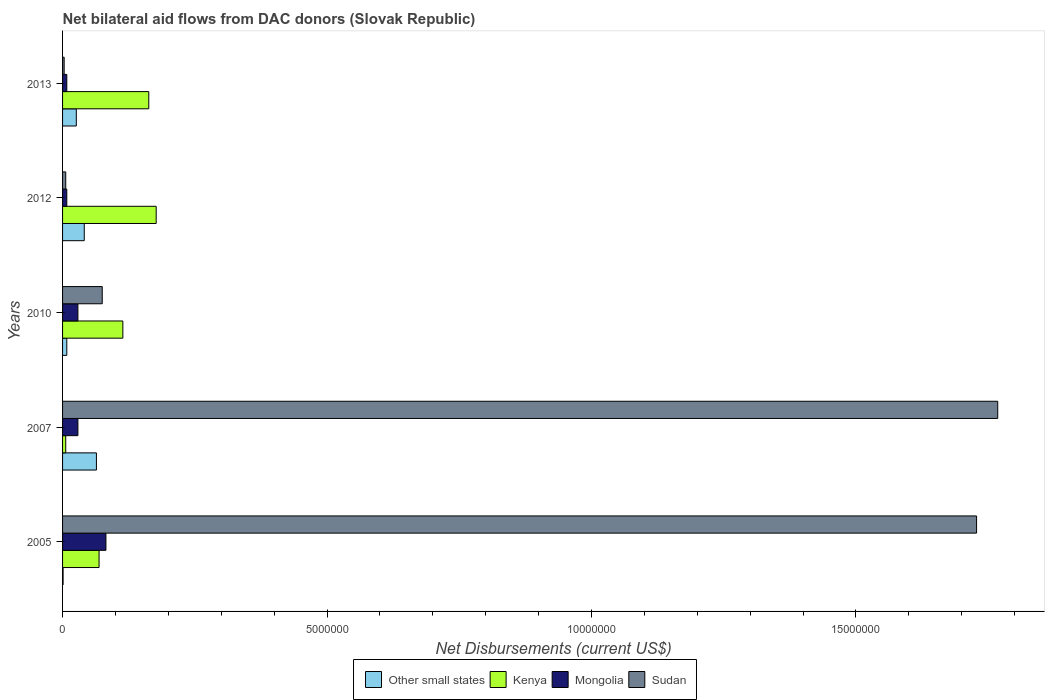How many different coloured bars are there?
Give a very brief answer. 4. How many groups of bars are there?
Ensure brevity in your answer.  5. Are the number of bars per tick equal to the number of legend labels?
Provide a short and direct response. Yes. What is the label of the 2nd group of bars from the top?
Your answer should be very brief. 2012. In how many cases, is the number of bars for a given year not equal to the number of legend labels?
Make the answer very short. 0. Across all years, what is the maximum net bilateral aid flows in Mongolia?
Your answer should be very brief. 8.20e+05. What is the total net bilateral aid flows in Kenya in the graph?
Your answer should be very brief. 5.29e+06. What is the difference between the net bilateral aid flows in Sudan in 2005 and that in 2007?
Offer a very short reply. -4.00e+05. What is the difference between the net bilateral aid flows in Other small states in 2007 and the net bilateral aid flows in Kenya in 2012?
Give a very brief answer. -1.13e+06. In the year 2013, what is the difference between the net bilateral aid flows in Kenya and net bilateral aid flows in Sudan?
Provide a short and direct response. 1.60e+06. What is the ratio of the net bilateral aid flows in Other small states in 2010 to that in 2013?
Your response must be concise. 0.31. What is the difference between the highest and the lowest net bilateral aid flows in Other small states?
Your answer should be very brief. 6.30e+05. Is the sum of the net bilateral aid flows in Other small states in 2007 and 2012 greater than the maximum net bilateral aid flows in Mongolia across all years?
Your answer should be compact. Yes. Is it the case that in every year, the sum of the net bilateral aid flows in Mongolia and net bilateral aid flows in Sudan is greater than the sum of net bilateral aid flows in Kenya and net bilateral aid flows in Other small states?
Ensure brevity in your answer.  No. What does the 2nd bar from the top in 2007 represents?
Offer a very short reply. Mongolia. What does the 3rd bar from the bottom in 2012 represents?
Ensure brevity in your answer.  Mongolia. How many bars are there?
Keep it short and to the point. 20. Are all the bars in the graph horizontal?
Your answer should be very brief. Yes. How many years are there in the graph?
Keep it short and to the point. 5. Are the values on the major ticks of X-axis written in scientific E-notation?
Give a very brief answer. No. Does the graph contain grids?
Your response must be concise. No. Where does the legend appear in the graph?
Offer a terse response. Bottom center. How many legend labels are there?
Provide a short and direct response. 4. How are the legend labels stacked?
Make the answer very short. Horizontal. What is the title of the graph?
Your answer should be very brief. Net bilateral aid flows from DAC donors (Slovak Republic). What is the label or title of the X-axis?
Your response must be concise. Net Disbursements (current US$). What is the Net Disbursements (current US$) in Kenya in 2005?
Provide a short and direct response. 6.90e+05. What is the Net Disbursements (current US$) of Mongolia in 2005?
Provide a short and direct response. 8.20e+05. What is the Net Disbursements (current US$) in Sudan in 2005?
Your answer should be very brief. 1.73e+07. What is the Net Disbursements (current US$) in Other small states in 2007?
Ensure brevity in your answer.  6.40e+05. What is the Net Disbursements (current US$) in Mongolia in 2007?
Give a very brief answer. 2.90e+05. What is the Net Disbursements (current US$) in Sudan in 2007?
Ensure brevity in your answer.  1.77e+07. What is the Net Disbursements (current US$) in Kenya in 2010?
Provide a short and direct response. 1.14e+06. What is the Net Disbursements (current US$) of Sudan in 2010?
Give a very brief answer. 7.50e+05. What is the Net Disbursements (current US$) of Kenya in 2012?
Ensure brevity in your answer.  1.77e+06. What is the Net Disbursements (current US$) in Sudan in 2012?
Ensure brevity in your answer.  6.00e+04. What is the Net Disbursements (current US$) of Kenya in 2013?
Keep it short and to the point. 1.63e+06. Across all years, what is the maximum Net Disbursements (current US$) in Other small states?
Offer a terse response. 6.40e+05. Across all years, what is the maximum Net Disbursements (current US$) in Kenya?
Your response must be concise. 1.77e+06. Across all years, what is the maximum Net Disbursements (current US$) in Mongolia?
Offer a very short reply. 8.20e+05. Across all years, what is the maximum Net Disbursements (current US$) of Sudan?
Make the answer very short. 1.77e+07. Across all years, what is the minimum Net Disbursements (current US$) in Other small states?
Give a very brief answer. 10000. Across all years, what is the minimum Net Disbursements (current US$) in Mongolia?
Offer a terse response. 8.00e+04. What is the total Net Disbursements (current US$) in Other small states in the graph?
Make the answer very short. 1.40e+06. What is the total Net Disbursements (current US$) of Kenya in the graph?
Make the answer very short. 5.29e+06. What is the total Net Disbursements (current US$) in Mongolia in the graph?
Keep it short and to the point. 1.56e+06. What is the total Net Disbursements (current US$) of Sudan in the graph?
Provide a short and direct response. 3.58e+07. What is the difference between the Net Disbursements (current US$) of Other small states in 2005 and that in 2007?
Provide a short and direct response. -6.30e+05. What is the difference between the Net Disbursements (current US$) in Kenya in 2005 and that in 2007?
Offer a terse response. 6.30e+05. What is the difference between the Net Disbursements (current US$) in Mongolia in 2005 and that in 2007?
Ensure brevity in your answer.  5.30e+05. What is the difference between the Net Disbursements (current US$) in Sudan in 2005 and that in 2007?
Offer a very short reply. -4.00e+05. What is the difference between the Net Disbursements (current US$) in Other small states in 2005 and that in 2010?
Offer a very short reply. -7.00e+04. What is the difference between the Net Disbursements (current US$) of Kenya in 2005 and that in 2010?
Your answer should be compact. -4.50e+05. What is the difference between the Net Disbursements (current US$) of Mongolia in 2005 and that in 2010?
Provide a succinct answer. 5.30e+05. What is the difference between the Net Disbursements (current US$) in Sudan in 2005 and that in 2010?
Make the answer very short. 1.65e+07. What is the difference between the Net Disbursements (current US$) of Other small states in 2005 and that in 2012?
Provide a succinct answer. -4.00e+05. What is the difference between the Net Disbursements (current US$) in Kenya in 2005 and that in 2012?
Keep it short and to the point. -1.08e+06. What is the difference between the Net Disbursements (current US$) in Mongolia in 2005 and that in 2012?
Make the answer very short. 7.40e+05. What is the difference between the Net Disbursements (current US$) in Sudan in 2005 and that in 2012?
Provide a succinct answer. 1.72e+07. What is the difference between the Net Disbursements (current US$) in Other small states in 2005 and that in 2013?
Provide a short and direct response. -2.50e+05. What is the difference between the Net Disbursements (current US$) in Kenya in 2005 and that in 2013?
Provide a succinct answer. -9.40e+05. What is the difference between the Net Disbursements (current US$) of Mongolia in 2005 and that in 2013?
Offer a terse response. 7.40e+05. What is the difference between the Net Disbursements (current US$) of Sudan in 2005 and that in 2013?
Offer a terse response. 1.72e+07. What is the difference between the Net Disbursements (current US$) of Other small states in 2007 and that in 2010?
Ensure brevity in your answer.  5.60e+05. What is the difference between the Net Disbursements (current US$) in Kenya in 2007 and that in 2010?
Your answer should be compact. -1.08e+06. What is the difference between the Net Disbursements (current US$) in Mongolia in 2007 and that in 2010?
Your answer should be very brief. 0. What is the difference between the Net Disbursements (current US$) in Sudan in 2007 and that in 2010?
Your answer should be compact. 1.69e+07. What is the difference between the Net Disbursements (current US$) in Kenya in 2007 and that in 2012?
Make the answer very short. -1.71e+06. What is the difference between the Net Disbursements (current US$) of Mongolia in 2007 and that in 2012?
Your answer should be very brief. 2.10e+05. What is the difference between the Net Disbursements (current US$) in Sudan in 2007 and that in 2012?
Make the answer very short. 1.76e+07. What is the difference between the Net Disbursements (current US$) of Kenya in 2007 and that in 2013?
Ensure brevity in your answer.  -1.57e+06. What is the difference between the Net Disbursements (current US$) of Sudan in 2007 and that in 2013?
Your answer should be compact. 1.76e+07. What is the difference between the Net Disbursements (current US$) in Other small states in 2010 and that in 2012?
Your response must be concise. -3.30e+05. What is the difference between the Net Disbursements (current US$) in Kenya in 2010 and that in 2012?
Offer a terse response. -6.30e+05. What is the difference between the Net Disbursements (current US$) of Sudan in 2010 and that in 2012?
Offer a terse response. 6.90e+05. What is the difference between the Net Disbursements (current US$) in Kenya in 2010 and that in 2013?
Offer a terse response. -4.90e+05. What is the difference between the Net Disbursements (current US$) of Mongolia in 2010 and that in 2013?
Your response must be concise. 2.10e+05. What is the difference between the Net Disbursements (current US$) of Sudan in 2010 and that in 2013?
Keep it short and to the point. 7.20e+05. What is the difference between the Net Disbursements (current US$) in Other small states in 2005 and the Net Disbursements (current US$) in Mongolia in 2007?
Provide a short and direct response. -2.80e+05. What is the difference between the Net Disbursements (current US$) of Other small states in 2005 and the Net Disbursements (current US$) of Sudan in 2007?
Provide a short and direct response. -1.77e+07. What is the difference between the Net Disbursements (current US$) of Kenya in 2005 and the Net Disbursements (current US$) of Mongolia in 2007?
Your answer should be compact. 4.00e+05. What is the difference between the Net Disbursements (current US$) in Kenya in 2005 and the Net Disbursements (current US$) in Sudan in 2007?
Keep it short and to the point. -1.70e+07. What is the difference between the Net Disbursements (current US$) of Mongolia in 2005 and the Net Disbursements (current US$) of Sudan in 2007?
Your response must be concise. -1.69e+07. What is the difference between the Net Disbursements (current US$) in Other small states in 2005 and the Net Disbursements (current US$) in Kenya in 2010?
Your answer should be compact. -1.13e+06. What is the difference between the Net Disbursements (current US$) of Other small states in 2005 and the Net Disbursements (current US$) of Mongolia in 2010?
Offer a very short reply. -2.80e+05. What is the difference between the Net Disbursements (current US$) of Other small states in 2005 and the Net Disbursements (current US$) of Sudan in 2010?
Provide a succinct answer. -7.40e+05. What is the difference between the Net Disbursements (current US$) of Other small states in 2005 and the Net Disbursements (current US$) of Kenya in 2012?
Provide a short and direct response. -1.76e+06. What is the difference between the Net Disbursements (current US$) in Kenya in 2005 and the Net Disbursements (current US$) in Mongolia in 2012?
Keep it short and to the point. 6.10e+05. What is the difference between the Net Disbursements (current US$) in Kenya in 2005 and the Net Disbursements (current US$) in Sudan in 2012?
Offer a very short reply. 6.30e+05. What is the difference between the Net Disbursements (current US$) of Mongolia in 2005 and the Net Disbursements (current US$) of Sudan in 2012?
Provide a succinct answer. 7.60e+05. What is the difference between the Net Disbursements (current US$) of Other small states in 2005 and the Net Disbursements (current US$) of Kenya in 2013?
Keep it short and to the point. -1.62e+06. What is the difference between the Net Disbursements (current US$) in Other small states in 2005 and the Net Disbursements (current US$) in Sudan in 2013?
Your response must be concise. -2.00e+04. What is the difference between the Net Disbursements (current US$) in Kenya in 2005 and the Net Disbursements (current US$) in Sudan in 2013?
Ensure brevity in your answer.  6.60e+05. What is the difference between the Net Disbursements (current US$) of Mongolia in 2005 and the Net Disbursements (current US$) of Sudan in 2013?
Provide a short and direct response. 7.90e+05. What is the difference between the Net Disbursements (current US$) in Other small states in 2007 and the Net Disbursements (current US$) in Kenya in 2010?
Offer a terse response. -5.00e+05. What is the difference between the Net Disbursements (current US$) of Other small states in 2007 and the Net Disbursements (current US$) of Mongolia in 2010?
Provide a succinct answer. 3.50e+05. What is the difference between the Net Disbursements (current US$) of Other small states in 2007 and the Net Disbursements (current US$) of Sudan in 2010?
Keep it short and to the point. -1.10e+05. What is the difference between the Net Disbursements (current US$) of Kenya in 2007 and the Net Disbursements (current US$) of Sudan in 2010?
Provide a short and direct response. -6.90e+05. What is the difference between the Net Disbursements (current US$) of Mongolia in 2007 and the Net Disbursements (current US$) of Sudan in 2010?
Provide a succinct answer. -4.60e+05. What is the difference between the Net Disbursements (current US$) of Other small states in 2007 and the Net Disbursements (current US$) of Kenya in 2012?
Give a very brief answer. -1.13e+06. What is the difference between the Net Disbursements (current US$) of Other small states in 2007 and the Net Disbursements (current US$) of Mongolia in 2012?
Keep it short and to the point. 5.60e+05. What is the difference between the Net Disbursements (current US$) of Other small states in 2007 and the Net Disbursements (current US$) of Sudan in 2012?
Provide a short and direct response. 5.80e+05. What is the difference between the Net Disbursements (current US$) in Mongolia in 2007 and the Net Disbursements (current US$) in Sudan in 2012?
Give a very brief answer. 2.30e+05. What is the difference between the Net Disbursements (current US$) of Other small states in 2007 and the Net Disbursements (current US$) of Kenya in 2013?
Provide a short and direct response. -9.90e+05. What is the difference between the Net Disbursements (current US$) in Other small states in 2007 and the Net Disbursements (current US$) in Mongolia in 2013?
Keep it short and to the point. 5.60e+05. What is the difference between the Net Disbursements (current US$) in Other small states in 2007 and the Net Disbursements (current US$) in Sudan in 2013?
Give a very brief answer. 6.10e+05. What is the difference between the Net Disbursements (current US$) of Kenya in 2007 and the Net Disbursements (current US$) of Mongolia in 2013?
Offer a terse response. -2.00e+04. What is the difference between the Net Disbursements (current US$) in Mongolia in 2007 and the Net Disbursements (current US$) in Sudan in 2013?
Your answer should be compact. 2.60e+05. What is the difference between the Net Disbursements (current US$) in Other small states in 2010 and the Net Disbursements (current US$) in Kenya in 2012?
Your answer should be very brief. -1.69e+06. What is the difference between the Net Disbursements (current US$) in Other small states in 2010 and the Net Disbursements (current US$) in Mongolia in 2012?
Your response must be concise. 0. What is the difference between the Net Disbursements (current US$) of Kenya in 2010 and the Net Disbursements (current US$) of Mongolia in 2012?
Provide a short and direct response. 1.06e+06. What is the difference between the Net Disbursements (current US$) of Kenya in 2010 and the Net Disbursements (current US$) of Sudan in 2012?
Keep it short and to the point. 1.08e+06. What is the difference between the Net Disbursements (current US$) of Mongolia in 2010 and the Net Disbursements (current US$) of Sudan in 2012?
Offer a terse response. 2.30e+05. What is the difference between the Net Disbursements (current US$) of Other small states in 2010 and the Net Disbursements (current US$) of Kenya in 2013?
Your response must be concise. -1.55e+06. What is the difference between the Net Disbursements (current US$) in Other small states in 2010 and the Net Disbursements (current US$) in Mongolia in 2013?
Keep it short and to the point. 0. What is the difference between the Net Disbursements (current US$) of Other small states in 2010 and the Net Disbursements (current US$) of Sudan in 2013?
Offer a very short reply. 5.00e+04. What is the difference between the Net Disbursements (current US$) in Kenya in 2010 and the Net Disbursements (current US$) in Mongolia in 2013?
Your answer should be very brief. 1.06e+06. What is the difference between the Net Disbursements (current US$) of Kenya in 2010 and the Net Disbursements (current US$) of Sudan in 2013?
Your answer should be compact. 1.11e+06. What is the difference between the Net Disbursements (current US$) in Mongolia in 2010 and the Net Disbursements (current US$) in Sudan in 2013?
Make the answer very short. 2.60e+05. What is the difference between the Net Disbursements (current US$) of Other small states in 2012 and the Net Disbursements (current US$) of Kenya in 2013?
Provide a succinct answer. -1.22e+06. What is the difference between the Net Disbursements (current US$) of Other small states in 2012 and the Net Disbursements (current US$) of Sudan in 2013?
Your response must be concise. 3.80e+05. What is the difference between the Net Disbursements (current US$) of Kenya in 2012 and the Net Disbursements (current US$) of Mongolia in 2013?
Offer a terse response. 1.69e+06. What is the difference between the Net Disbursements (current US$) of Kenya in 2012 and the Net Disbursements (current US$) of Sudan in 2013?
Make the answer very short. 1.74e+06. What is the average Net Disbursements (current US$) in Other small states per year?
Offer a very short reply. 2.80e+05. What is the average Net Disbursements (current US$) of Kenya per year?
Provide a short and direct response. 1.06e+06. What is the average Net Disbursements (current US$) of Mongolia per year?
Your response must be concise. 3.12e+05. What is the average Net Disbursements (current US$) of Sudan per year?
Make the answer very short. 7.16e+06. In the year 2005, what is the difference between the Net Disbursements (current US$) of Other small states and Net Disbursements (current US$) of Kenya?
Ensure brevity in your answer.  -6.80e+05. In the year 2005, what is the difference between the Net Disbursements (current US$) in Other small states and Net Disbursements (current US$) in Mongolia?
Give a very brief answer. -8.10e+05. In the year 2005, what is the difference between the Net Disbursements (current US$) of Other small states and Net Disbursements (current US$) of Sudan?
Your response must be concise. -1.73e+07. In the year 2005, what is the difference between the Net Disbursements (current US$) of Kenya and Net Disbursements (current US$) of Mongolia?
Ensure brevity in your answer.  -1.30e+05. In the year 2005, what is the difference between the Net Disbursements (current US$) of Kenya and Net Disbursements (current US$) of Sudan?
Offer a very short reply. -1.66e+07. In the year 2005, what is the difference between the Net Disbursements (current US$) in Mongolia and Net Disbursements (current US$) in Sudan?
Your answer should be compact. -1.65e+07. In the year 2007, what is the difference between the Net Disbursements (current US$) of Other small states and Net Disbursements (current US$) of Kenya?
Offer a very short reply. 5.80e+05. In the year 2007, what is the difference between the Net Disbursements (current US$) in Other small states and Net Disbursements (current US$) in Mongolia?
Offer a terse response. 3.50e+05. In the year 2007, what is the difference between the Net Disbursements (current US$) of Other small states and Net Disbursements (current US$) of Sudan?
Provide a short and direct response. -1.70e+07. In the year 2007, what is the difference between the Net Disbursements (current US$) in Kenya and Net Disbursements (current US$) in Sudan?
Your answer should be very brief. -1.76e+07. In the year 2007, what is the difference between the Net Disbursements (current US$) of Mongolia and Net Disbursements (current US$) of Sudan?
Your answer should be very brief. -1.74e+07. In the year 2010, what is the difference between the Net Disbursements (current US$) of Other small states and Net Disbursements (current US$) of Kenya?
Your answer should be very brief. -1.06e+06. In the year 2010, what is the difference between the Net Disbursements (current US$) of Other small states and Net Disbursements (current US$) of Mongolia?
Provide a short and direct response. -2.10e+05. In the year 2010, what is the difference between the Net Disbursements (current US$) of Other small states and Net Disbursements (current US$) of Sudan?
Give a very brief answer. -6.70e+05. In the year 2010, what is the difference between the Net Disbursements (current US$) of Kenya and Net Disbursements (current US$) of Mongolia?
Ensure brevity in your answer.  8.50e+05. In the year 2010, what is the difference between the Net Disbursements (current US$) in Mongolia and Net Disbursements (current US$) in Sudan?
Keep it short and to the point. -4.60e+05. In the year 2012, what is the difference between the Net Disbursements (current US$) in Other small states and Net Disbursements (current US$) in Kenya?
Provide a short and direct response. -1.36e+06. In the year 2012, what is the difference between the Net Disbursements (current US$) in Kenya and Net Disbursements (current US$) in Mongolia?
Offer a terse response. 1.69e+06. In the year 2012, what is the difference between the Net Disbursements (current US$) in Kenya and Net Disbursements (current US$) in Sudan?
Your response must be concise. 1.71e+06. In the year 2012, what is the difference between the Net Disbursements (current US$) in Mongolia and Net Disbursements (current US$) in Sudan?
Ensure brevity in your answer.  2.00e+04. In the year 2013, what is the difference between the Net Disbursements (current US$) of Other small states and Net Disbursements (current US$) of Kenya?
Ensure brevity in your answer.  -1.37e+06. In the year 2013, what is the difference between the Net Disbursements (current US$) in Other small states and Net Disbursements (current US$) in Mongolia?
Give a very brief answer. 1.80e+05. In the year 2013, what is the difference between the Net Disbursements (current US$) of Kenya and Net Disbursements (current US$) of Mongolia?
Provide a succinct answer. 1.55e+06. In the year 2013, what is the difference between the Net Disbursements (current US$) in Kenya and Net Disbursements (current US$) in Sudan?
Your answer should be compact. 1.60e+06. In the year 2013, what is the difference between the Net Disbursements (current US$) of Mongolia and Net Disbursements (current US$) of Sudan?
Your answer should be very brief. 5.00e+04. What is the ratio of the Net Disbursements (current US$) of Other small states in 2005 to that in 2007?
Offer a terse response. 0.02. What is the ratio of the Net Disbursements (current US$) in Kenya in 2005 to that in 2007?
Give a very brief answer. 11.5. What is the ratio of the Net Disbursements (current US$) of Mongolia in 2005 to that in 2007?
Provide a succinct answer. 2.83. What is the ratio of the Net Disbursements (current US$) of Sudan in 2005 to that in 2007?
Your answer should be compact. 0.98. What is the ratio of the Net Disbursements (current US$) in Kenya in 2005 to that in 2010?
Provide a succinct answer. 0.61. What is the ratio of the Net Disbursements (current US$) of Mongolia in 2005 to that in 2010?
Provide a succinct answer. 2.83. What is the ratio of the Net Disbursements (current US$) in Sudan in 2005 to that in 2010?
Provide a short and direct response. 23.04. What is the ratio of the Net Disbursements (current US$) of Other small states in 2005 to that in 2012?
Give a very brief answer. 0.02. What is the ratio of the Net Disbursements (current US$) of Kenya in 2005 to that in 2012?
Your answer should be very brief. 0.39. What is the ratio of the Net Disbursements (current US$) of Mongolia in 2005 to that in 2012?
Your answer should be very brief. 10.25. What is the ratio of the Net Disbursements (current US$) of Sudan in 2005 to that in 2012?
Your answer should be compact. 288. What is the ratio of the Net Disbursements (current US$) of Other small states in 2005 to that in 2013?
Ensure brevity in your answer.  0.04. What is the ratio of the Net Disbursements (current US$) of Kenya in 2005 to that in 2013?
Your answer should be very brief. 0.42. What is the ratio of the Net Disbursements (current US$) of Mongolia in 2005 to that in 2013?
Your answer should be very brief. 10.25. What is the ratio of the Net Disbursements (current US$) in Sudan in 2005 to that in 2013?
Your answer should be compact. 576. What is the ratio of the Net Disbursements (current US$) of Kenya in 2007 to that in 2010?
Keep it short and to the point. 0.05. What is the ratio of the Net Disbursements (current US$) of Sudan in 2007 to that in 2010?
Provide a short and direct response. 23.57. What is the ratio of the Net Disbursements (current US$) in Other small states in 2007 to that in 2012?
Provide a succinct answer. 1.56. What is the ratio of the Net Disbursements (current US$) of Kenya in 2007 to that in 2012?
Your response must be concise. 0.03. What is the ratio of the Net Disbursements (current US$) of Mongolia in 2007 to that in 2012?
Your answer should be very brief. 3.62. What is the ratio of the Net Disbursements (current US$) in Sudan in 2007 to that in 2012?
Keep it short and to the point. 294.67. What is the ratio of the Net Disbursements (current US$) of Other small states in 2007 to that in 2013?
Your response must be concise. 2.46. What is the ratio of the Net Disbursements (current US$) in Kenya in 2007 to that in 2013?
Your response must be concise. 0.04. What is the ratio of the Net Disbursements (current US$) in Mongolia in 2007 to that in 2013?
Your response must be concise. 3.62. What is the ratio of the Net Disbursements (current US$) in Sudan in 2007 to that in 2013?
Your response must be concise. 589.33. What is the ratio of the Net Disbursements (current US$) in Other small states in 2010 to that in 2012?
Provide a succinct answer. 0.2. What is the ratio of the Net Disbursements (current US$) in Kenya in 2010 to that in 2012?
Make the answer very short. 0.64. What is the ratio of the Net Disbursements (current US$) in Mongolia in 2010 to that in 2012?
Give a very brief answer. 3.62. What is the ratio of the Net Disbursements (current US$) in Other small states in 2010 to that in 2013?
Ensure brevity in your answer.  0.31. What is the ratio of the Net Disbursements (current US$) of Kenya in 2010 to that in 2013?
Ensure brevity in your answer.  0.7. What is the ratio of the Net Disbursements (current US$) in Mongolia in 2010 to that in 2013?
Keep it short and to the point. 3.62. What is the ratio of the Net Disbursements (current US$) in Sudan in 2010 to that in 2013?
Your answer should be very brief. 25. What is the ratio of the Net Disbursements (current US$) of Other small states in 2012 to that in 2013?
Offer a very short reply. 1.58. What is the ratio of the Net Disbursements (current US$) of Kenya in 2012 to that in 2013?
Your answer should be compact. 1.09. What is the difference between the highest and the second highest Net Disbursements (current US$) of Mongolia?
Your answer should be compact. 5.30e+05. What is the difference between the highest and the lowest Net Disbursements (current US$) of Other small states?
Make the answer very short. 6.30e+05. What is the difference between the highest and the lowest Net Disbursements (current US$) in Kenya?
Your answer should be very brief. 1.71e+06. What is the difference between the highest and the lowest Net Disbursements (current US$) of Mongolia?
Give a very brief answer. 7.40e+05. What is the difference between the highest and the lowest Net Disbursements (current US$) in Sudan?
Give a very brief answer. 1.76e+07. 